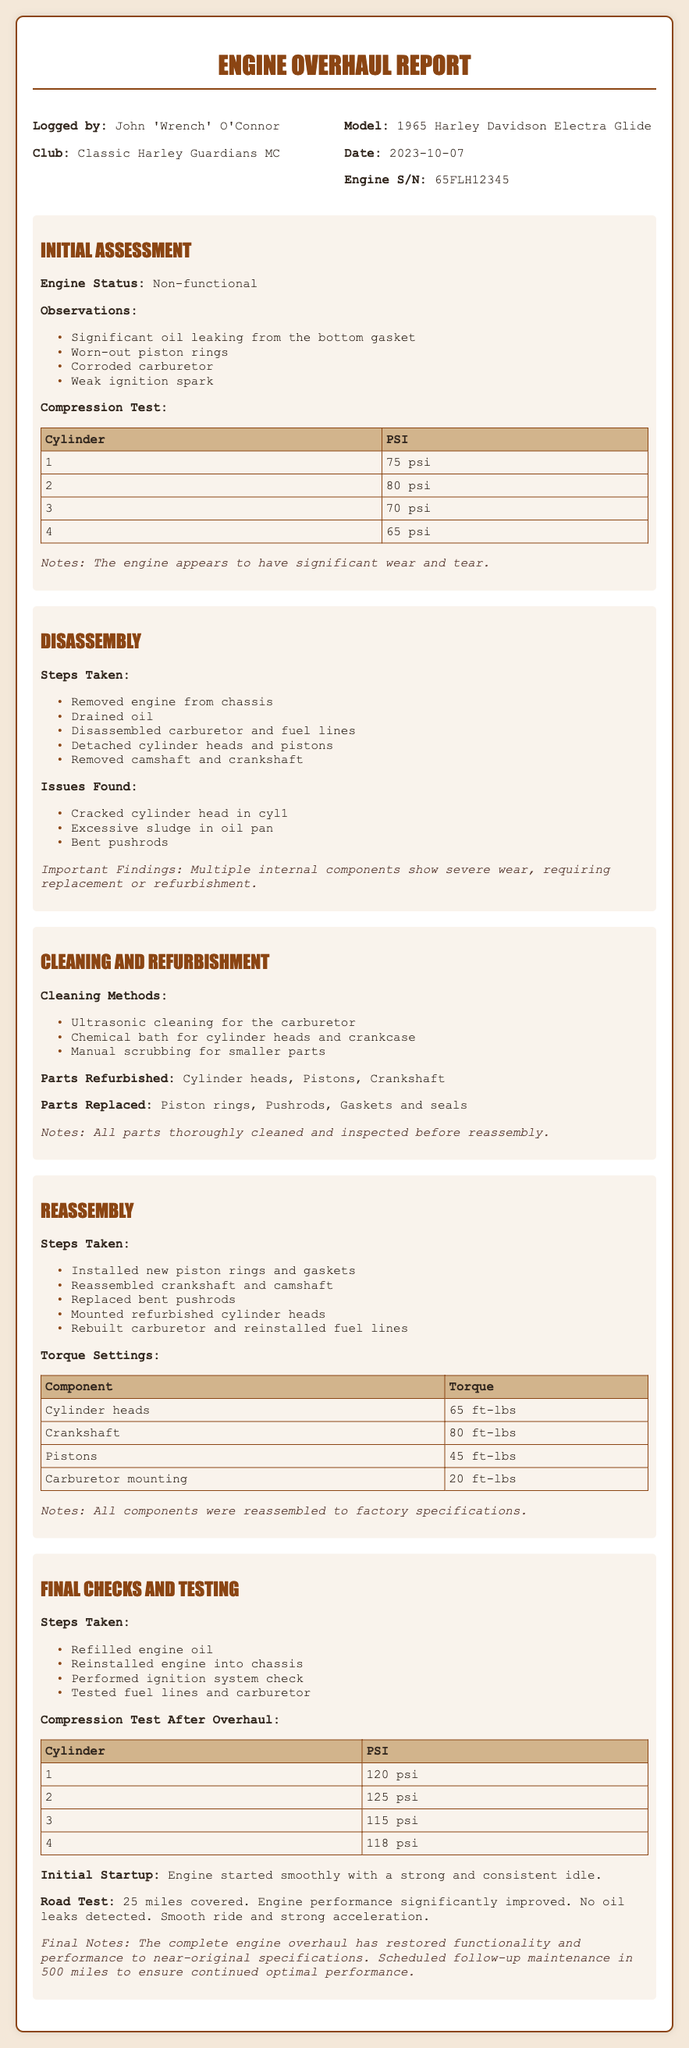what is the model of the motorcycle? The model is mentioned in the document under 'Model:', indicating the specific motorcycle being worked on.
Answer: 1965 Harley Davidson Electra Glide who logged the report? The name of the individual who logged the report is provided in the 'Logged by:' section, detailing the individual's identity.
Answer: John 'Wrench' O'Connor what was the engine status at the beginning? The engine status is listed as 'Non-functional', indicating its initial condition before any work was done.
Answer: Non-functional how many miles were covered during the road test? The document includes a section on the road test where the distance covered is clearly stated.
Answer: 25 miles what were the PSI readings for cylinder 1 after the overhaul? The document provides a specific section detailing the compression test results after the overhaul, with cylinder-by-cylinder readings.
Answer: 120 psi what cleaning method was used for the carburetor? The cleaning methods are listed, specifying which method was employed for the carburetor cleaning.
Answer: Ultrasonic cleaning how many pushrods were replaced during the overhaul? The overhaul documentation provides information on parts that were replaced, including pushrods.
Answer: Bent pushrods what component has a torque setting of 80 ft-lbs? The torque settings table lists various components with their corresponding torque values, highlighting one that requires 80 ft-lbs.
Answer: Crankshaft when is the scheduled follow-up maintenance? The final section mentions a follow-up maintenance schedule, indicating when the next check is set.
Answer: 500 miles 